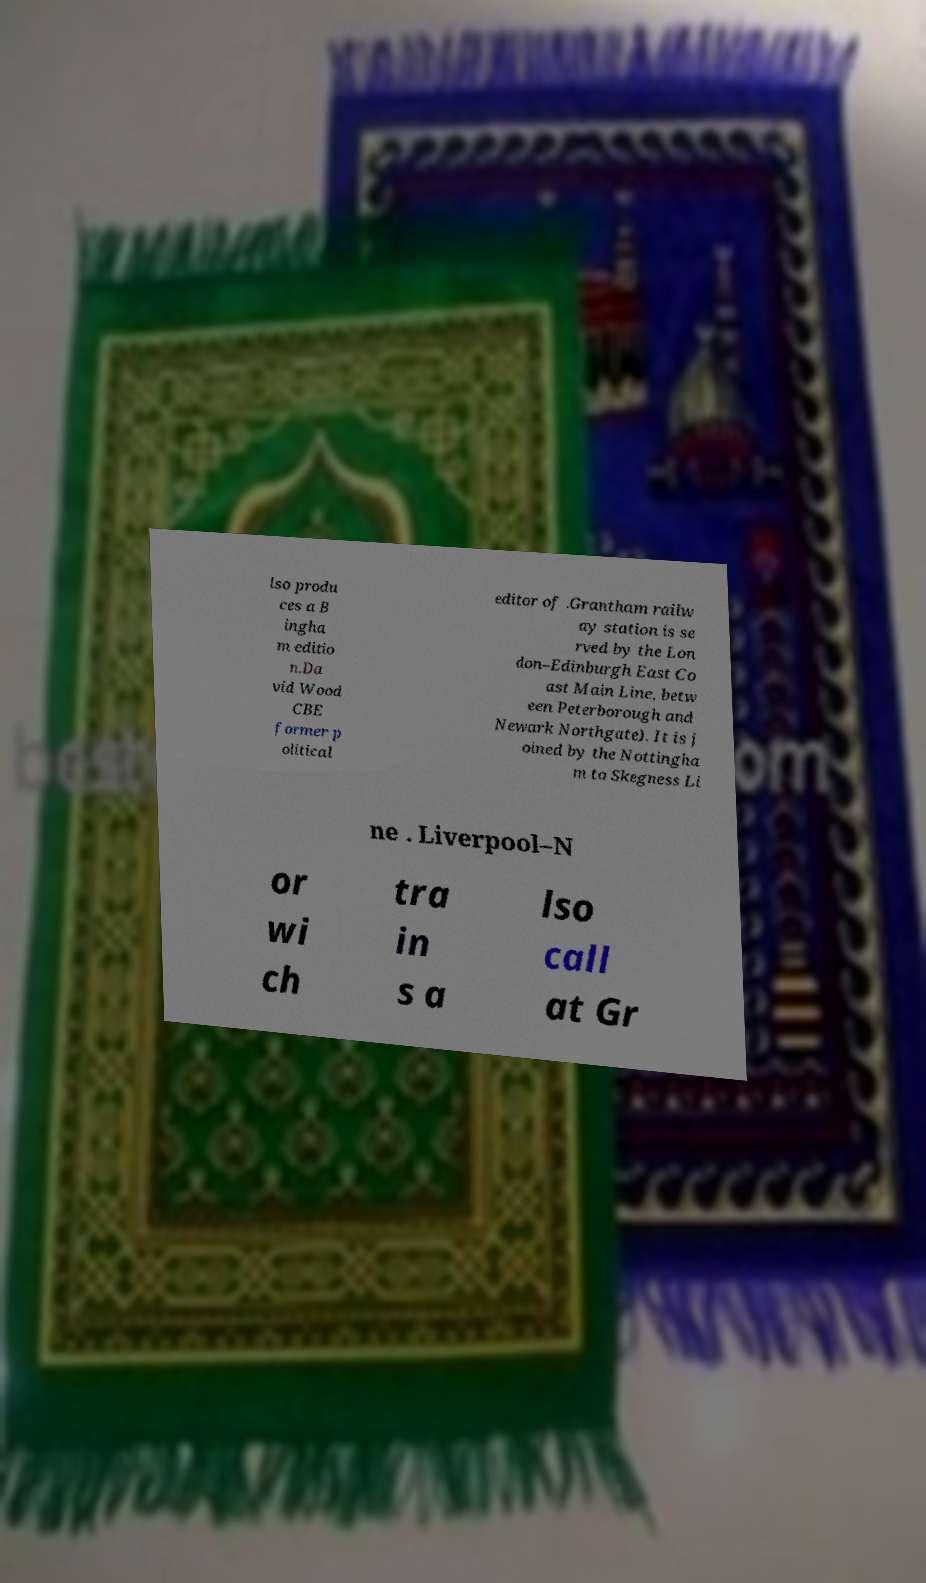Can you read and provide the text displayed in the image?This photo seems to have some interesting text. Can you extract and type it out for me? lso produ ces a B ingha m editio n.Da vid Wood CBE former p olitical editor of .Grantham railw ay station is se rved by the Lon don–Edinburgh East Co ast Main Line, betw een Peterborough and Newark Northgate). It is j oined by the Nottingha m to Skegness Li ne . Liverpool–N or wi ch tra in s a lso call at Gr 